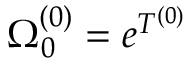<formula> <loc_0><loc_0><loc_500><loc_500>\Omega _ { 0 } ^ { ( 0 ) } = e ^ { T ^ { ( 0 ) } }</formula> 